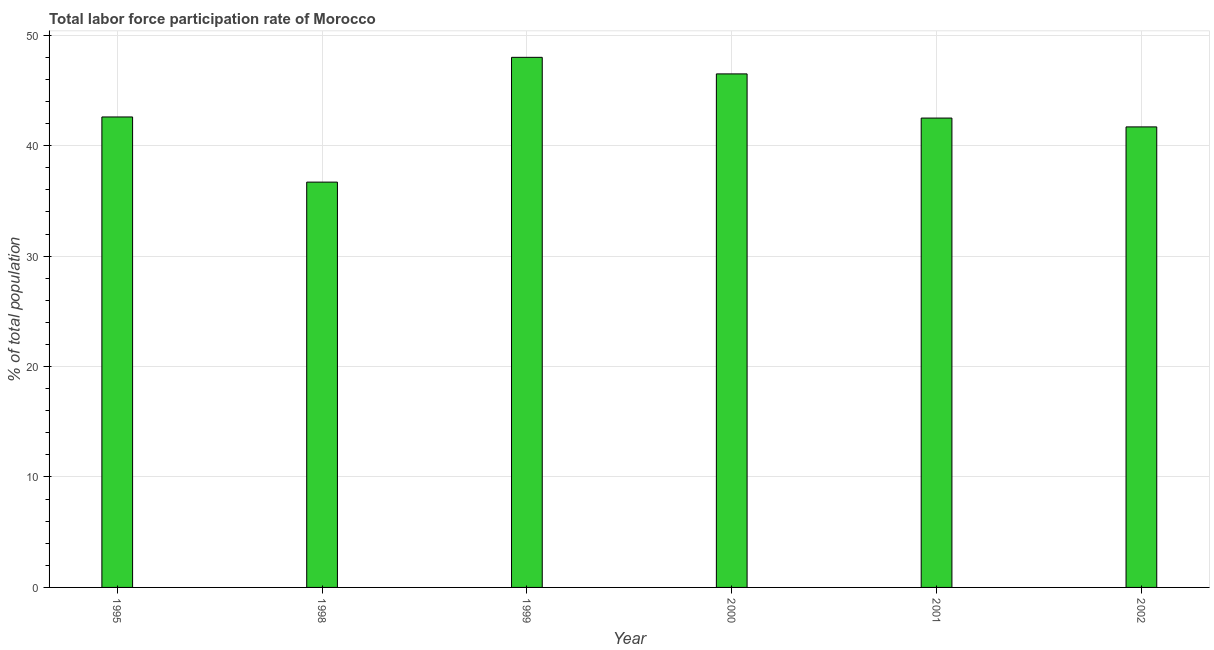Does the graph contain grids?
Provide a short and direct response. Yes. What is the title of the graph?
Offer a terse response. Total labor force participation rate of Morocco. What is the label or title of the X-axis?
Offer a terse response. Year. What is the label or title of the Y-axis?
Keep it short and to the point. % of total population. What is the total labor force participation rate in 2002?
Make the answer very short. 41.7. Across all years, what is the minimum total labor force participation rate?
Your answer should be very brief. 36.7. In which year was the total labor force participation rate maximum?
Make the answer very short. 1999. What is the sum of the total labor force participation rate?
Make the answer very short. 258. What is the median total labor force participation rate?
Your answer should be compact. 42.55. What is the ratio of the total labor force participation rate in 2000 to that in 2002?
Ensure brevity in your answer.  1.11. Is the total labor force participation rate in 1999 less than that in 2001?
Make the answer very short. No. Is the difference between the total labor force participation rate in 1995 and 1998 greater than the difference between any two years?
Give a very brief answer. No. How many bars are there?
Your response must be concise. 6. Are all the bars in the graph horizontal?
Provide a short and direct response. No. How many years are there in the graph?
Ensure brevity in your answer.  6. What is the difference between two consecutive major ticks on the Y-axis?
Ensure brevity in your answer.  10. Are the values on the major ticks of Y-axis written in scientific E-notation?
Provide a short and direct response. No. What is the % of total population of 1995?
Your answer should be very brief. 42.6. What is the % of total population of 1998?
Give a very brief answer. 36.7. What is the % of total population of 1999?
Keep it short and to the point. 48. What is the % of total population in 2000?
Offer a terse response. 46.5. What is the % of total population of 2001?
Ensure brevity in your answer.  42.5. What is the % of total population of 2002?
Your answer should be compact. 41.7. What is the difference between the % of total population in 1995 and 1999?
Make the answer very short. -5.4. What is the difference between the % of total population in 1995 and 2000?
Offer a very short reply. -3.9. What is the difference between the % of total population in 1995 and 2001?
Ensure brevity in your answer.  0.1. What is the difference between the % of total population in 1998 and 1999?
Offer a terse response. -11.3. What is the difference between the % of total population in 1998 and 2000?
Offer a very short reply. -9.8. What is the difference between the % of total population in 1998 and 2001?
Offer a very short reply. -5.8. What is the difference between the % of total population in 1998 and 2002?
Ensure brevity in your answer.  -5. What is the difference between the % of total population in 1999 and 2002?
Keep it short and to the point. 6.3. What is the difference between the % of total population in 2000 and 2001?
Give a very brief answer. 4. What is the difference between the % of total population in 2001 and 2002?
Keep it short and to the point. 0.8. What is the ratio of the % of total population in 1995 to that in 1998?
Provide a succinct answer. 1.16. What is the ratio of the % of total population in 1995 to that in 1999?
Ensure brevity in your answer.  0.89. What is the ratio of the % of total population in 1995 to that in 2000?
Ensure brevity in your answer.  0.92. What is the ratio of the % of total population in 1995 to that in 2002?
Your response must be concise. 1.02. What is the ratio of the % of total population in 1998 to that in 1999?
Ensure brevity in your answer.  0.77. What is the ratio of the % of total population in 1998 to that in 2000?
Provide a succinct answer. 0.79. What is the ratio of the % of total population in 1998 to that in 2001?
Provide a short and direct response. 0.86. What is the ratio of the % of total population in 1999 to that in 2000?
Make the answer very short. 1.03. What is the ratio of the % of total population in 1999 to that in 2001?
Make the answer very short. 1.13. What is the ratio of the % of total population in 1999 to that in 2002?
Your response must be concise. 1.15. What is the ratio of the % of total population in 2000 to that in 2001?
Give a very brief answer. 1.09. What is the ratio of the % of total population in 2000 to that in 2002?
Offer a terse response. 1.11. 